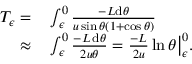<formula> <loc_0><loc_0><loc_500><loc_500>\begin{array} { r l } { T _ { \epsilon } = } & \int _ { \epsilon } ^ { 0 } \frac { - L d \theta } { u \sin \theta ( 1 + \cos \theta ) } } \\ { \approx } & \int _ { \epsilon } ^ { 0 } \frac { - L \, d \theta } { 2 u \theta } = \frac { - L } { 2 u } \ln \theta \Big | _ { \epsilon } ^ { 0 } . } \end{array}</formula> 